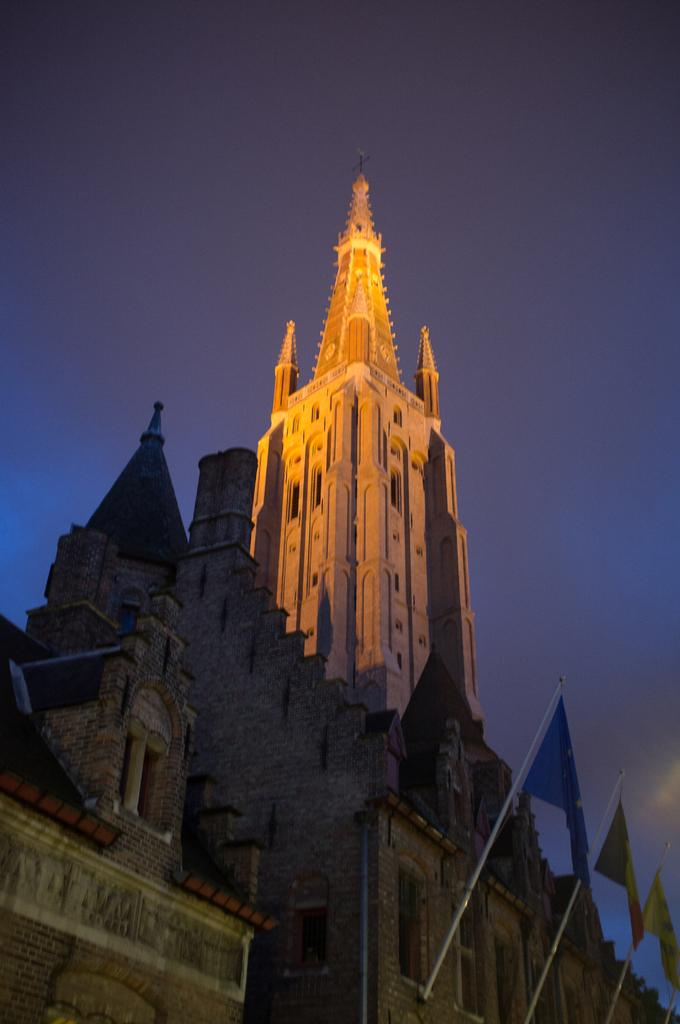What is located in the foreground of the picture? There are flags and a building in the foreground of the picture. What can be seen at the top of the picture? The sky is visible at the top of the picture. Can you tell me how much the judge paid for the boat in the image? There is no boat or judge present in the image, so it is not possible to determine any payment made. 